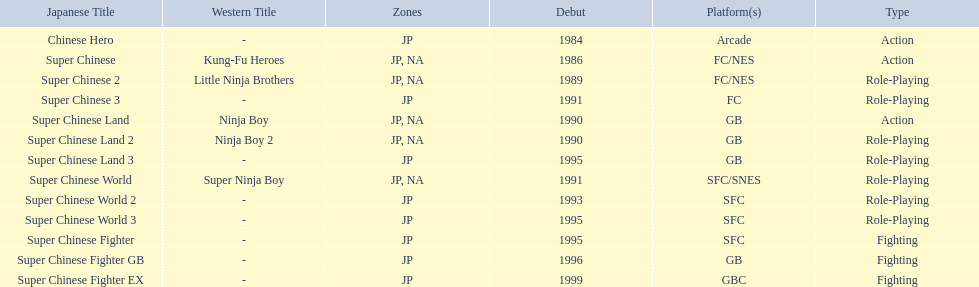What japanese titles were released in the north american (na) region? Super Chinese, Super Chinese 2, Super Chinese Land, Super Chinese Land 2, Super Chinese World. Of those, which one was released most recently? Super Chinese World. 